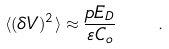Convert formula to latex. <formula><loc_0><loc_0><loc_500><loc_500>\langle ( \delta V ) ^ { 2 } \rangle \approx \frac { p E _ { D } } { \varepsilon C _ { o } } \quad .</formula> 